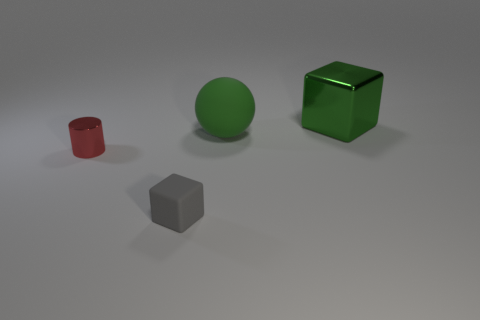Add 1 tiny gray balls. How many objects exist? 5 Add 2 tiny red metallic cylinders. How many tiny red metallic cylinders exist? 3 Subtract 1 red cylinders. How many objects are left? 3 Subtract all spheres. How many objects are left? 3 Subtract all tiny green rubber blocks. Subtract all green metal objects. How many objects are left? 3 Add 2 big shiny cubes. How many big shiny cubes are left? 3 